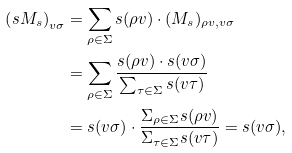Convert formula to latex. <formula><loc_0><loc_0><loc_500><loc_500>\left ( s M _ { s } \right ) _ { v \sigma } & = \sum _ { \rho \in \Sigma } s ( \rho v ) \cdot ( M _ { s } ) _ { \rho v , v \sigma } \\ & = \sum _ { \rho \in \Sigma } \frac { s ( \rho v ) \cdot s ( v \sigma ) } { \sum _ { \tau \in \Sigma } s ( v \tau ) } \\ & = s ( v \sigma ) \cdot \frac { \Sigma _ { \rho \in \Sigma } s ( \rho v ) } { \Sigma _ { \tau \in \Sigma } s ( v \tau ) } = s ( v \sigma ) ,</formula> 